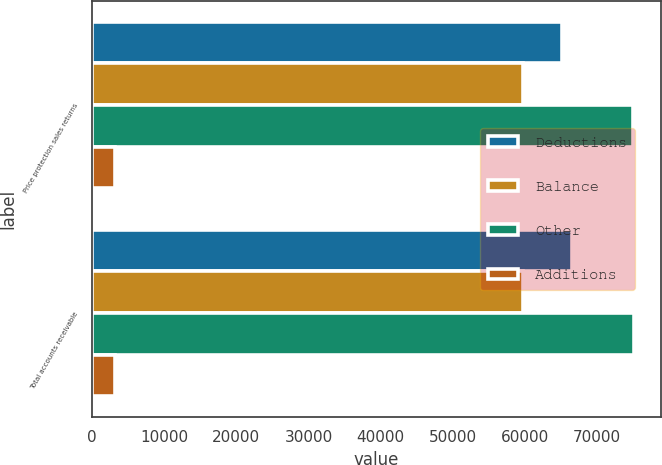Convert chart to OTSL. <chart><loc_0><loc_0><loc_500><loc_500><stacked_bar_chart><ecel><fcel>Price protection sales returns<fcel>Total accounts receivable<nl><fcel>Deductions<fcel>65114<fcel>66483<nl><fcel>Balance<fcel>59674<fcel>59674<nl><fcel>Other<fcel>74936<fcel>75058<nl><fcel>Additions<fcel>3191<fcel>3191<nl></chart> 